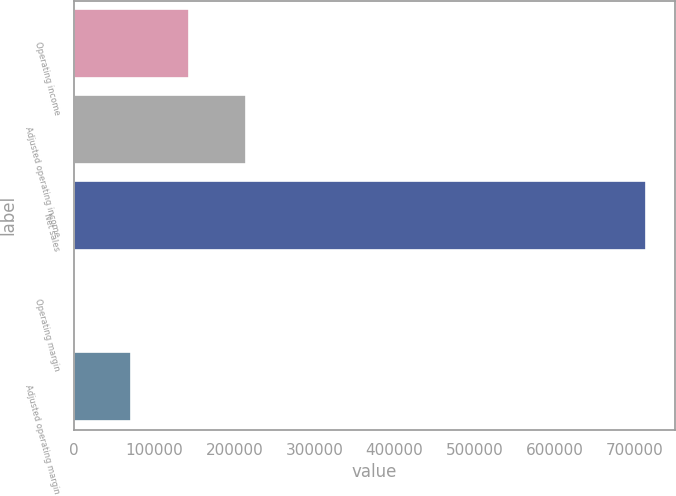Convert chart. <chart><loc_0><loc_0><loc_500><loc_500><bar_chart><fcel>Operating income<fcel>Adjusted operating income<fcel>Net sales<fcel>Operating margin<fcel>Adjusted operating margin<nl><fcel>142945<fcel>214408<fcel>714650<fcel>19.1<fcel>71482.2<nl></chart> 